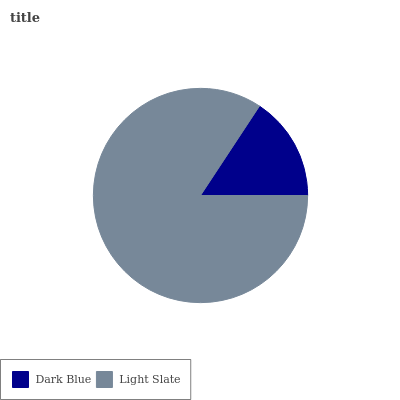Is Dark Blue the minimum?
Answer yes or no. Yes. Is Light Slate the maximum?
Answer yes or no. Yes. Is Light Slate the minimum?
Answer yes or no. No. Is Light Slate greater than Dark Blue?
Answer yes or no. Yes. Is Dark Blue less than Light Slate?
Answer yes or no. Yes. Is Dark Blue greater than Light Slate?
Answer yes or no. No. Is Light Slate less than Dark Blue?
Answer yes or no. No. Is Light Slate the high median?
Answer yes or no. Yes. Is Dark Blue the low median?
Answer yes or no. Yes. Is Dark Blue the high median?
Answer yes or no. No. Is Light Slate the low median?
Answer yes or no. No. 